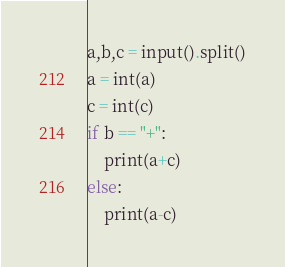Convert code to text. <code><loc_0><loc_0><loc_500><loc_500><_Python_>a,b,c = input().split()
a = int(a)
c = int(c)
if b == "+":
    print(a+c)
else:
    print(a-c)
</code> 